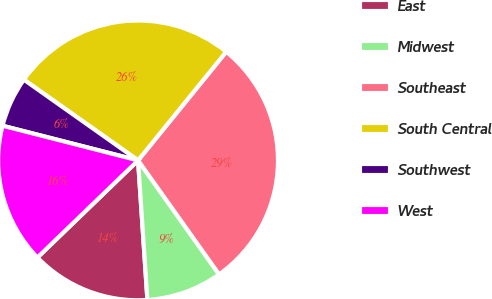Convert chart. <chart><loc_0><loc_0><loc_500><loc_500><pie_chart><fcel>East<fcel>Midwest<fcel>Southeast<fcel>South Central<fcel>Southwest<fcel>West<nl><fcel>13.85%<fcel>8.77%<fcel>29.32%<fcel>26.06%<fcel>5.81%<fcel>16.2%<nl></chart> 